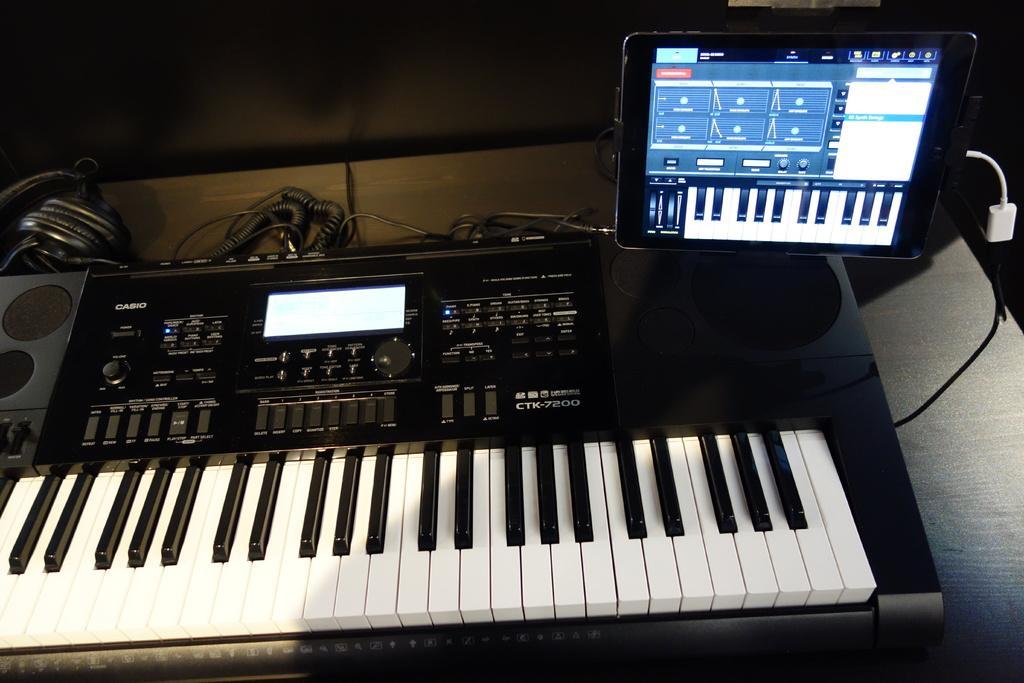How would you summarize this image in a sentence or two? In this image I can see a piano, a screen on the table. 